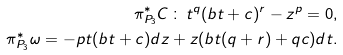Convert formula to latex. <formula><loc_0><loc_0><loc_500><loc_500>\pi ^ { * } _ { P _ { 3 } } C \, \colon \, t ^ { q } ( b t + c ) ^ { r } - z ^ { p } = 0 , \\ \pi ^ { * } _ { P _ { 3 } } \omega = - p t ( b t + c ) d z + z ( b t ( q + r ) + q c ) d t .</formula> 